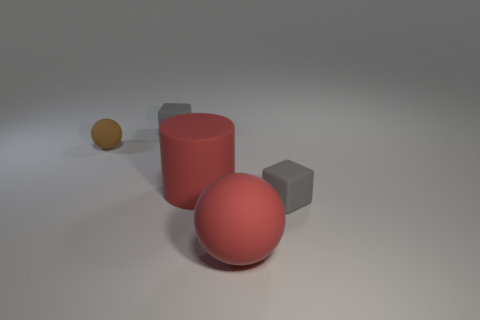Add 2 small balls. How many objects exist? 7 Subtract all cubes. How many objects are left? 3 Add 3 large blue rubber cylinders. How many large blue rubber cylinders exist? 3 Subtract 0 purple cylinders. How many objects are left? 5 Subtract all brown things. Subtract all tiny brown things. How many objects are left? 3 Add 1 tiny rubber balls. How many tiny rubber balls are left? 2 